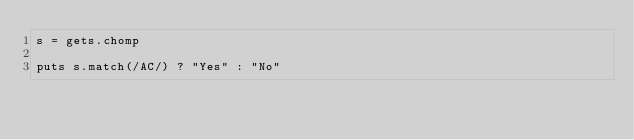Convert code to text. <code><loc_0><loc_0><loc_500><loc_500><_Ruby_>s = gets.chomp

puts s.match(/AC/) ? "Yes" : "No"</code> 